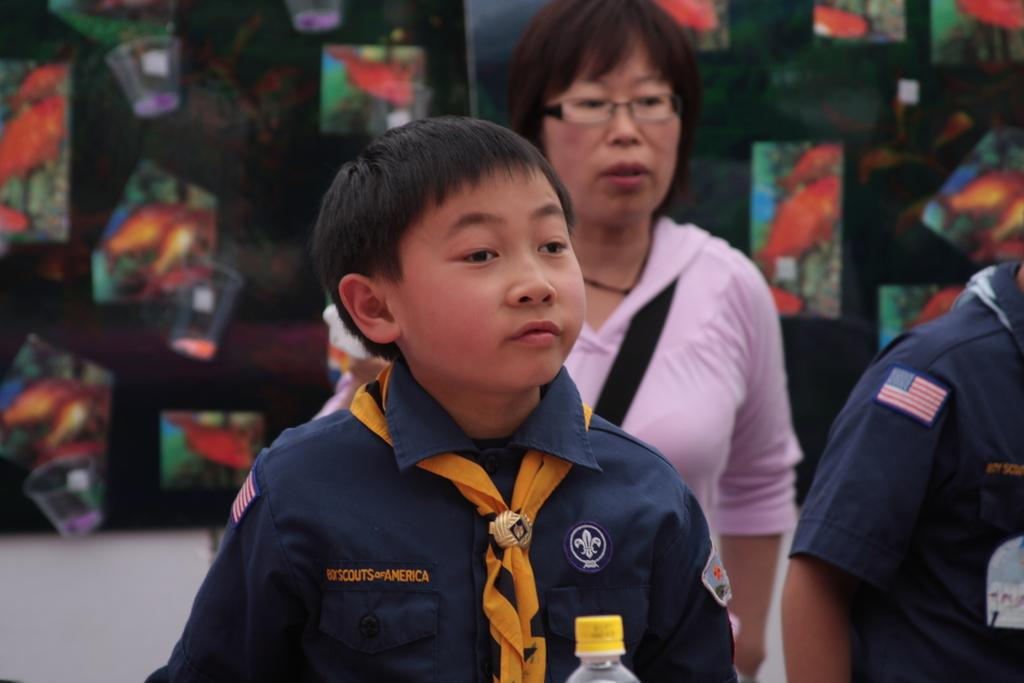How many people are in the image? There are people in the image, but the exact number is not specified. What is the boy in the center of the image doing? The boy is standing in the center of the image. What is the boy wearing? The boy is wearing a uniform. What object can be seen at the bottom of the image? There is a bottle at the bottom of the image. What can be seen on the wall in the background of the image? There are boards placed on the wall in the background of the image. What type of pie is the horse eating in the image? There is no horse or pie present in the image. 